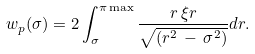<formula> <loc_0><loc_0><loc_500><loc_500>w _ { p } ( \sigma ) = 2 \int _ { \sigma } ^ { \pi \max } \frac { r \, \xi r } { \sqrt { ( r ^ { 2 } \, - \, \sigma ^ { 2 } ) } } d r .</formula> 